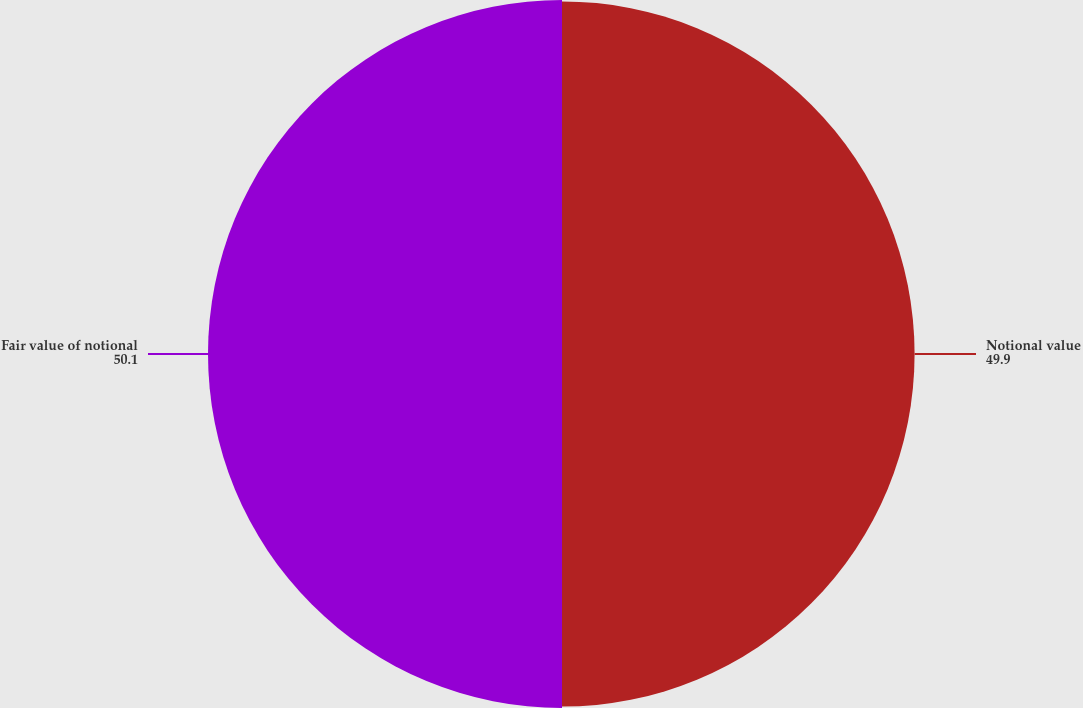Convert chart. <chart><loc_0><loc_0><loc_500><loc_500><pie_chart><fcel>Notional value<fcel>Fair value of notional<nl><fcel>49.9%<fcel>50.1%<nl></chart> 